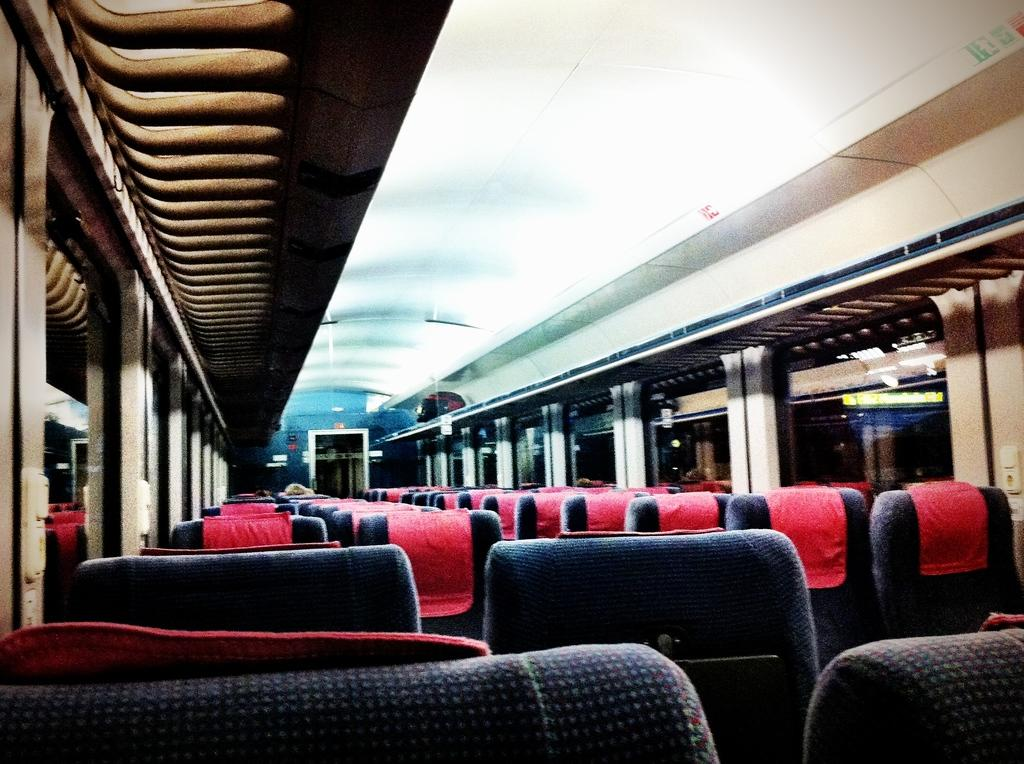What is the main subject of the image? The image shows the inner part of a vehicle. What colors are the chairs in the image? The chairs in the image are in blue and red colors. What type of material is used for the windows in the vehicle? There are glass windows visible in the image. Can you see any jellyfish swimming in the vehicle's interior in the image? No, there are no jellyfish present in the image. What type of plants can be seen growing inside the vehicle in the image? There are no plants visible in the image; it shows the interior of a vehicle with chairs and glass windows. 